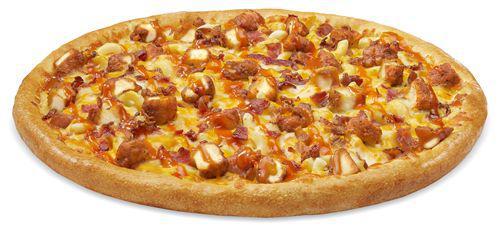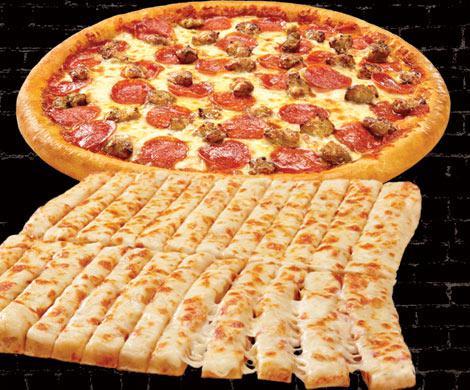The first image is the image on the left, the second image is the image on the right. Analyze the images presented: Is the assertion "There is a total of two circle pizzas." valid? Answer yes or no. Yes. 